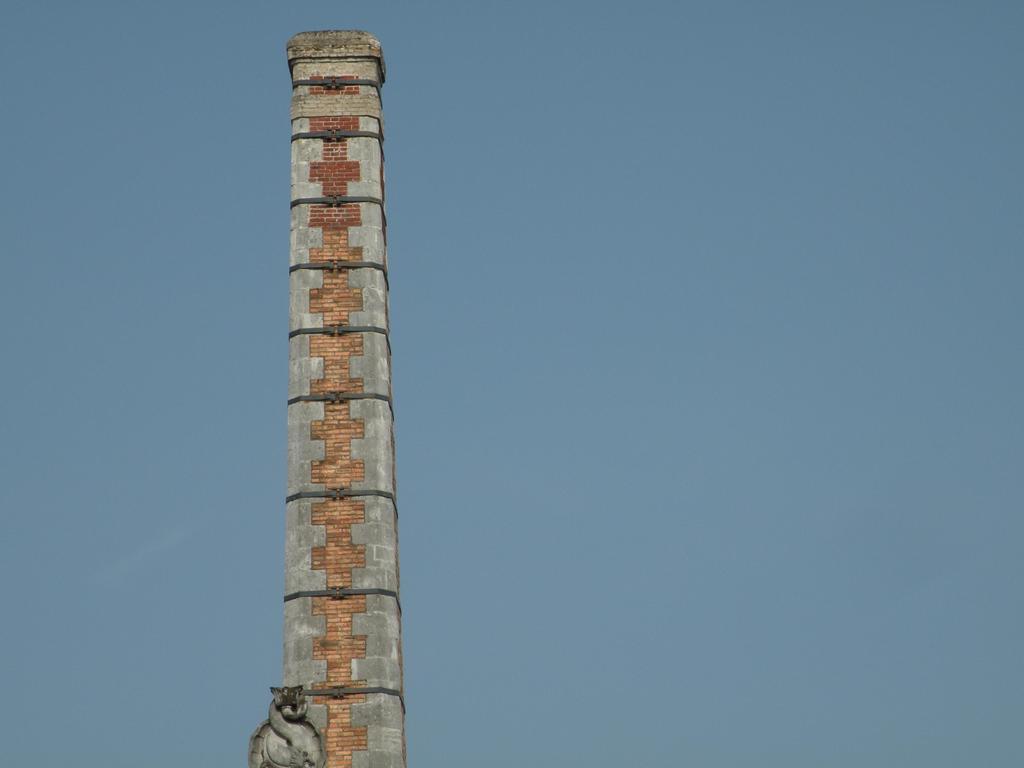How would you summarize this image in a sentence or two? In the middle of the image we can see a tower. 